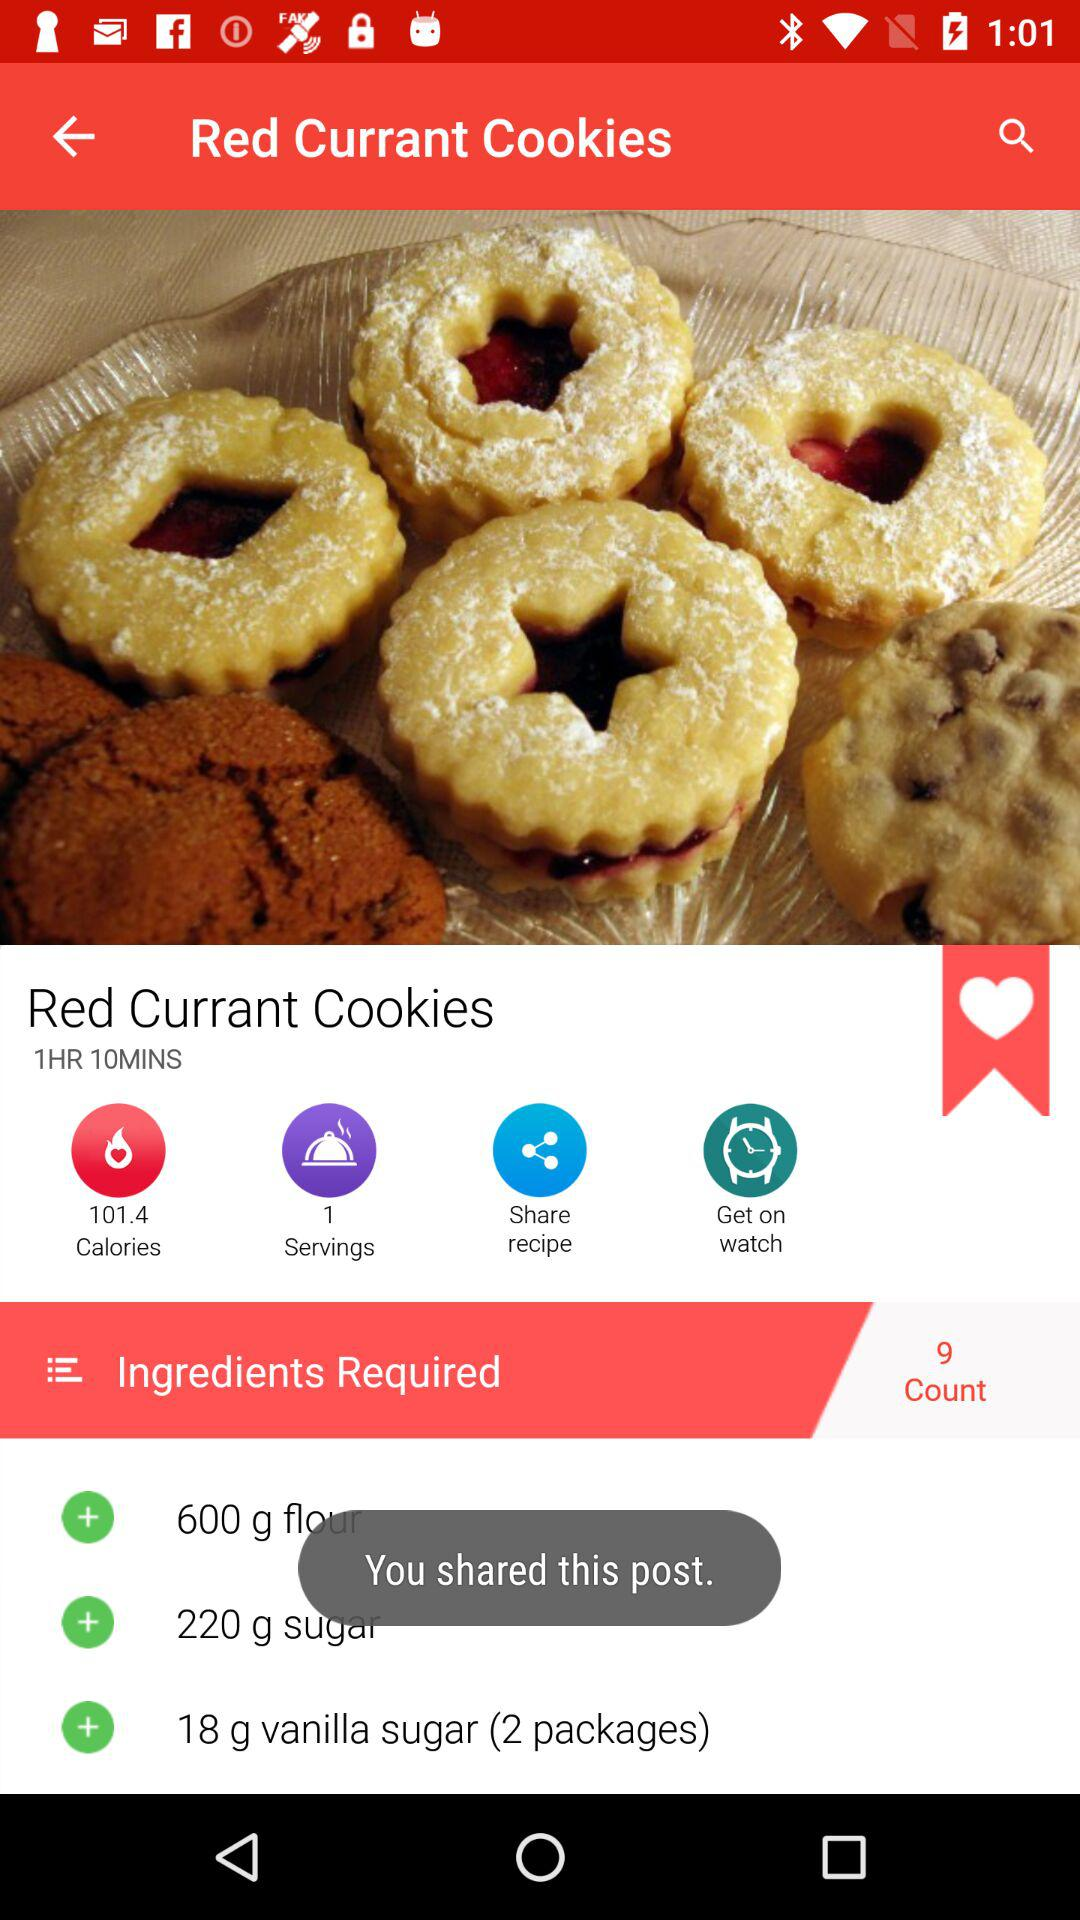How many grams of flour is required? There are 600 grams of flour required. 